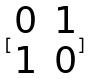<formula> <loc_0><loc_0><loc_500><loc_500>[ \begin{matrix} 0 & 1 \\ 1 & 0 \end{matrix} ]</formula> 